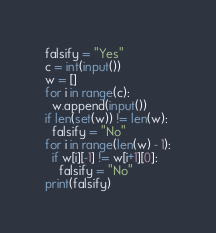<code> <loc_0><loc_0><loc_500><loc_500><_Python_>falsify = "Yes"
c = int(input())
w = []
for i in range(c):
  w.append(input())
if len(set(w)) != len(w):
  falsify = "No"
for i in range(len(w) - 1):
  if w[i][-1] != w[i+1][0]:
    falsify = "No"
print(falsify)</code> 